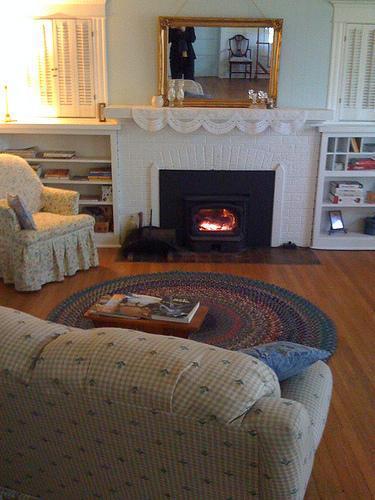How many mirrors?
Give a very brief answer. 1. 